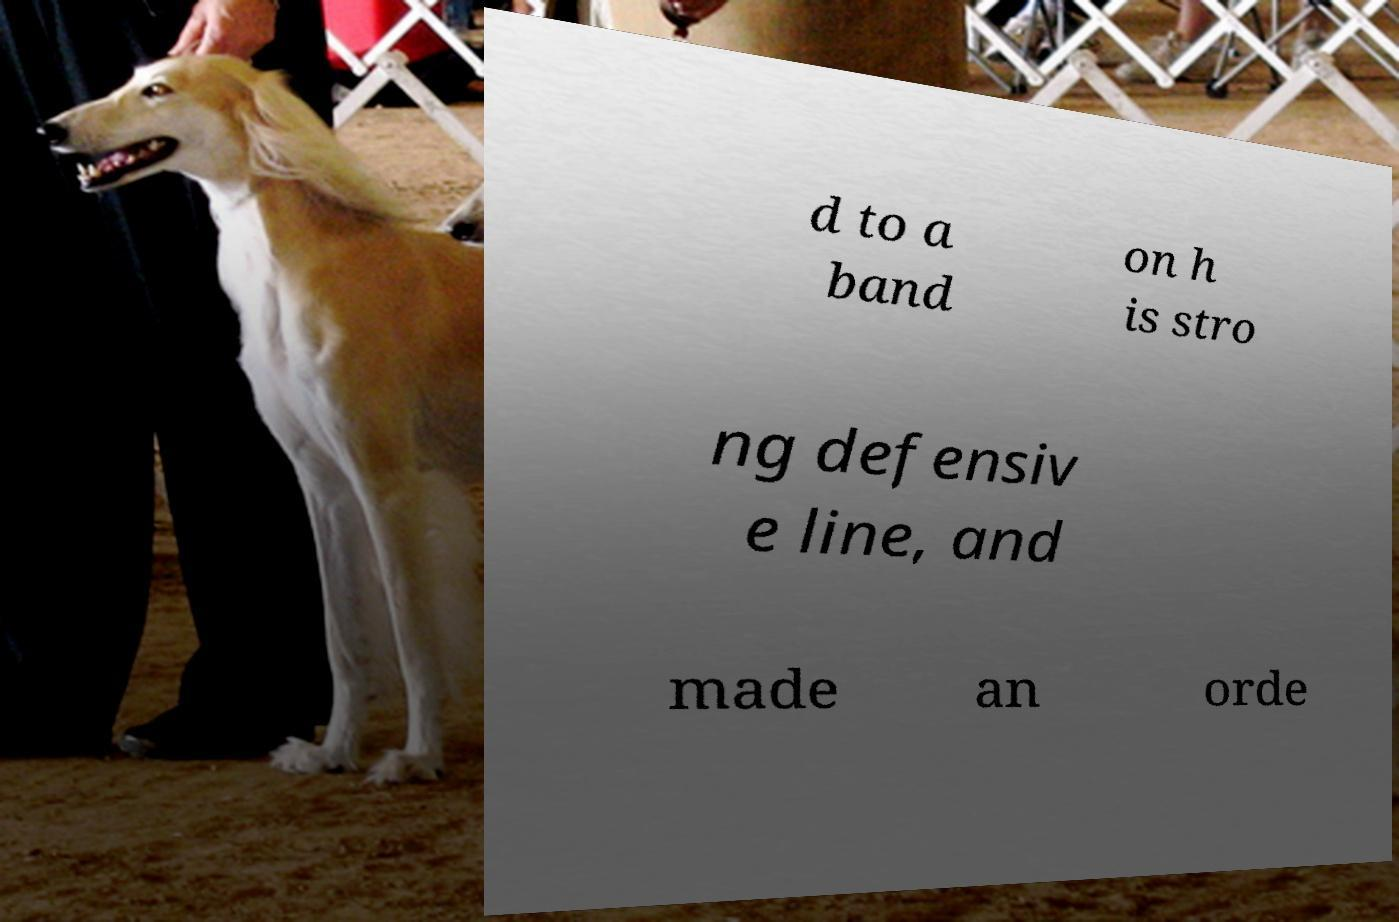Could you assist in decoding the text presented in this image and type it out clearly? d to a band on h is stro ng defensiv e line, and made an orde 